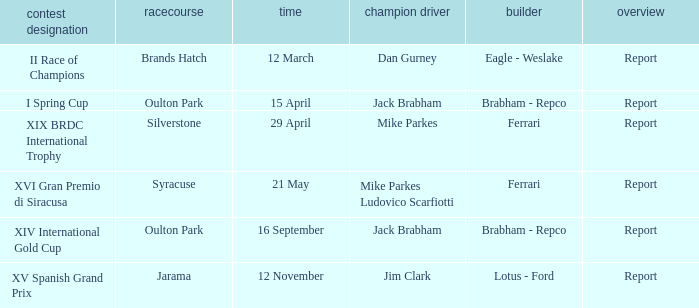What company constrcuted the vehicle with a circuit of oulton park on 15 april? Brabham - Repco. 